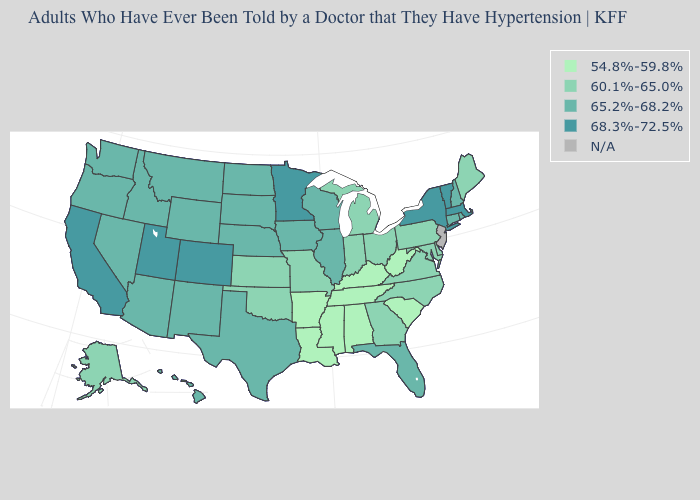Does the first symbol in the legend represent the smallest category?
Keep it brief. Yes. Name the states that have a value in the range 54.8%-59.8%?
Give a very brief answer. Alabama, Arkansas, Kentucky, Louisiana, Mississippi, South Carolina, Tennessee, West Virginia. Is the legend a continuous bar?
Short answer required. No. Name the states that have a value in the range 60.1%-65.0%?
Concise answer only. Alaska, Delaware, Georgia, Indiana, Kansas, Maine, Maryland, Michigan, Missouri, North Carolina, Ohio, Oklahoma, Pennsylvania, Virginia. Name the states that have a value in the range N/A?
Be succinct. New Jersey. Which states have the lowest value in the South?
Be succinct. Alabama, Arkansas, Kentucky, Louisiana, Mississippi, South Carolina, Tennessee, West Virginia. Name the states that have a value in the range 68.3%-72.5%?
Keep it brief. California, Colorado, Massachusetts, Minnesota, New York, Utah, Vermont. Which states hav the highest value in the West?
Answer briefly. California, Colorado, Utah. What is the value of Massachusetts?
Short answer required. 68.3%-72.5%. What is the value of Massachusetts?
Be succinct. 68.3%-72.5%. How many symbols are there in the legend?
Keep it brief. 5. Name the states that have a value in the range 60.1%-65.0%?
Be succinct. Alaska, Delaware, Georgia, Indiana, Kansas, Maine, Maryland, Michigan, Missouri, North Carolina, Ohio, Oklahoma, Pennsylvania, Virginia. 